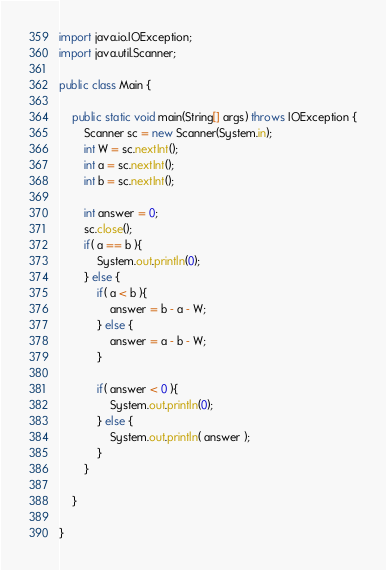Convert code to text. <code><loc_0><loc_0><loc_500><loc_500><_Java_>import java.io.IOException;
import java.util.Scanner;

public class Main {

	public static void main(String[] args) throws IOException {
		Scanner sc = new Scanner(System.in);
		int W = sc.nextInt();
		int a = sc.nextInt();
		int b = sc.nextInt();

		int answer = 0;
		sc.close();
		if( a == b ){
			System.out.println(0);
		} else {
			if( a < b ){
				answer = b - a - W;
			} else {
				answer = a - b - W;
			}

			if( answer < 0 ){
				System.out.println(0);
			} else {
				System.out.println( answer );
			}
		}

	}

}</code> 